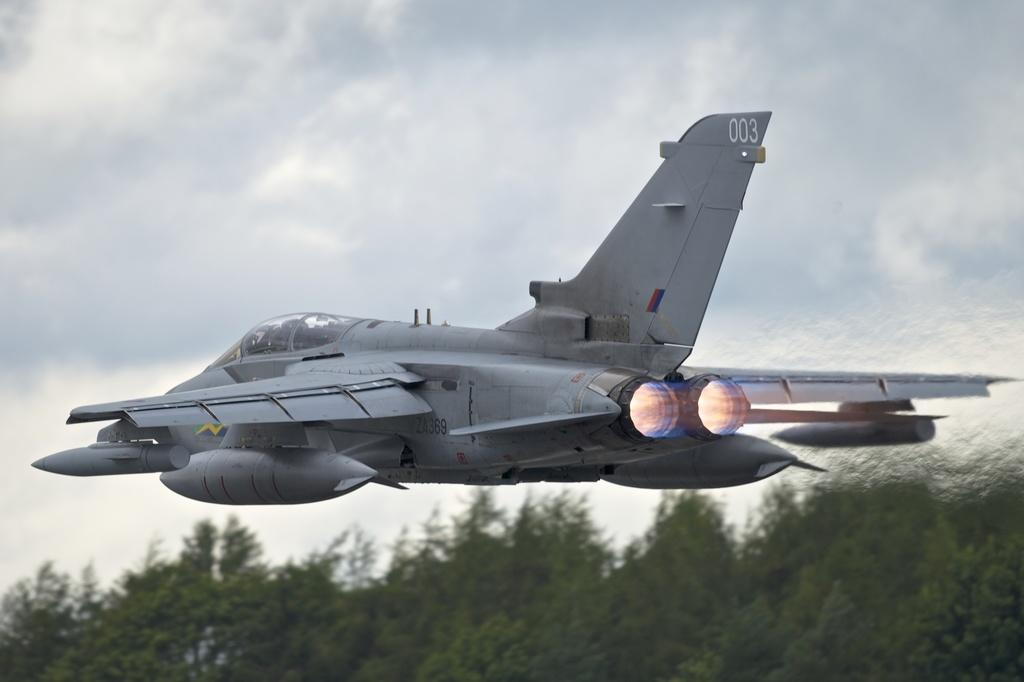What is the main subject of the image? The main subject of the image is an aircraft. What else can be seen in the image besides the aircraft? There are trees and the sky visible in the image. How does the cup rest on the aircraft in the image? There is no cup present in the image, so it cannot rest on the aircraft. 